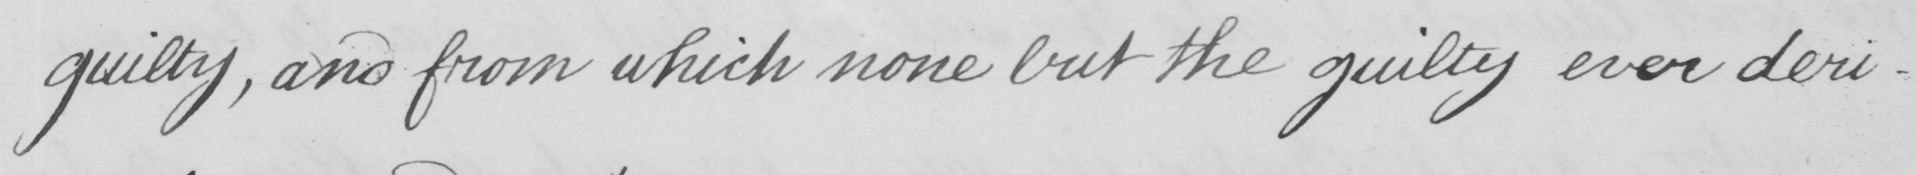What is written in this line of handwriting? guilty , and from which none but the guilty ever deri- 